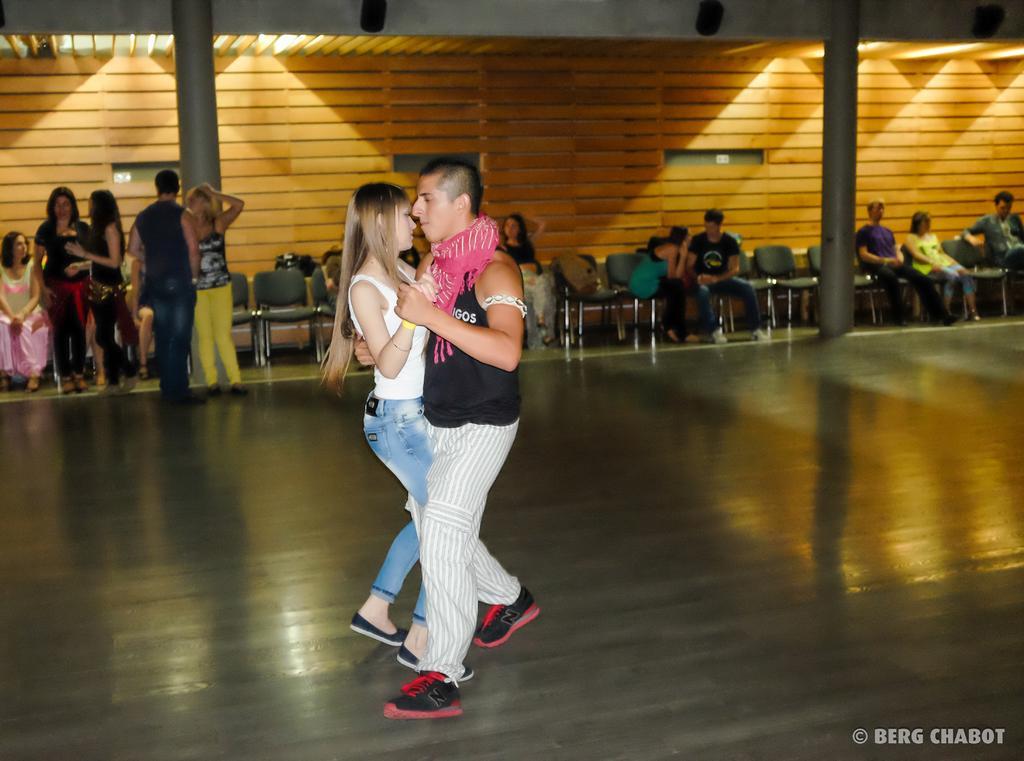How would you summarize this image in a sentence or two? In this image we can see a man and a woman are holding each other and dancing on the floor. In the background we can see few persons are standing on the floor, few persons are sitting on the chairs, empty chairs, objects, pillars, lights and wooden wall. 